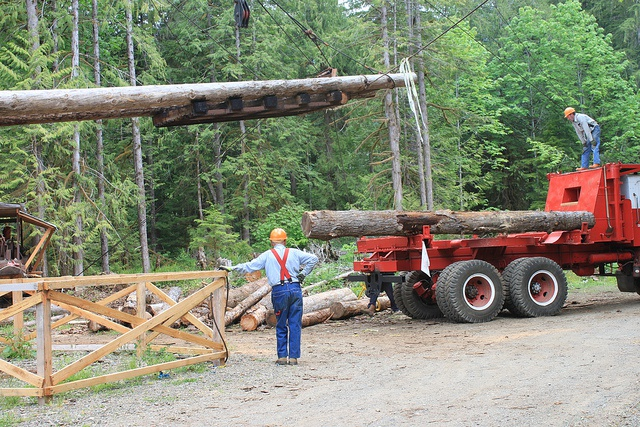Describe the objects in this image and their specific colors. I can see truck in green, black, gray, maroon, and brown tones, people in green, lightblue, blue, and navy tones, people in green, darkgray, and gray tones, and people in green, black, gray, and navy tones in this image. 